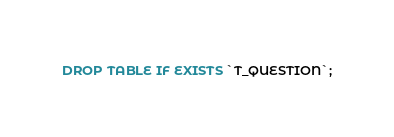<code> <loc_0><loc_0><loc_500><loc_500><_SQL_>DROP TABLE IF EXISTS `T_QUESTION`;
</code> 